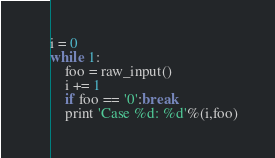Convert code to text. <code><loc_0><loc_0><loc_500><loc_500><_Python_>i = 0
while 1:
	foo = raw_input()
	i += 1
	if foo == '0':break
	print 'Case %d: %d'%(i,foo)</code> 